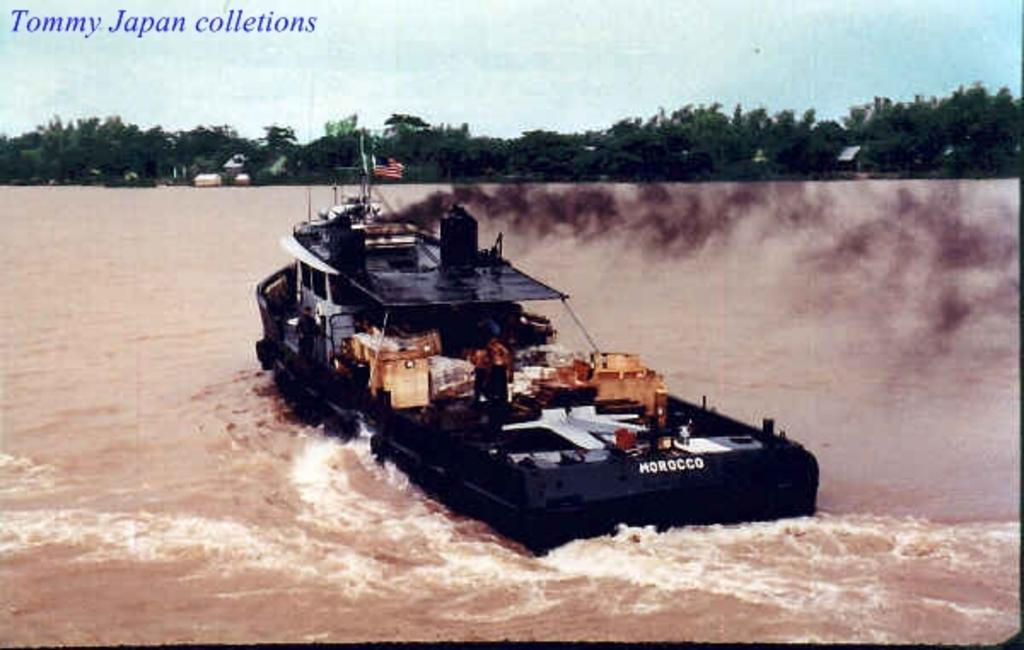What is the main subject of the image? The main subject of the image is a boat. What color is the boat? The boat is black in color. Where is the boat located in the image? The boat is on the water. What can be seen in the background of the image? Trees and the sky are visible in the background of the image. Is there any additional feature present in the image? Yes, there is a watermark in the image. What type of office furniture can be seen in the image? There is no office furniture present in the image; it features a black boat on the water. How many people are sitting in the middle of the boat in the image? There is no mention of people in the image, only a black boat on the water. 